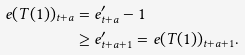Convert formula to latex. <formula><loc_0><loc_0><loc_500><loc_500>e ( T ( 1 ) ) _ { t + a } & = e ^ { \prime } _ { t + a } - 1 \\ & \geq e ^ { \prime } _ { t + a + 1 } = e ( T ( 1 ) ) _ { t + a + 1 } .</formula> 